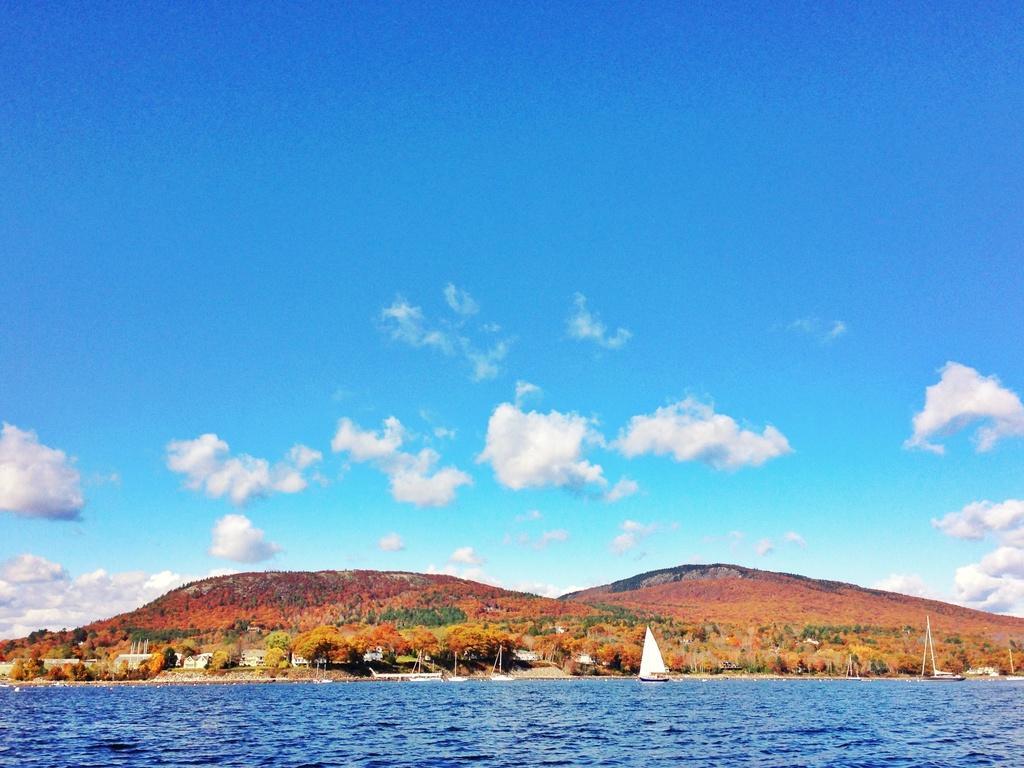Please provide a concise description of this image. At the bottom of the image, we can see boats, water, houses, trees and hills. Background we can see the cloudy sky. 